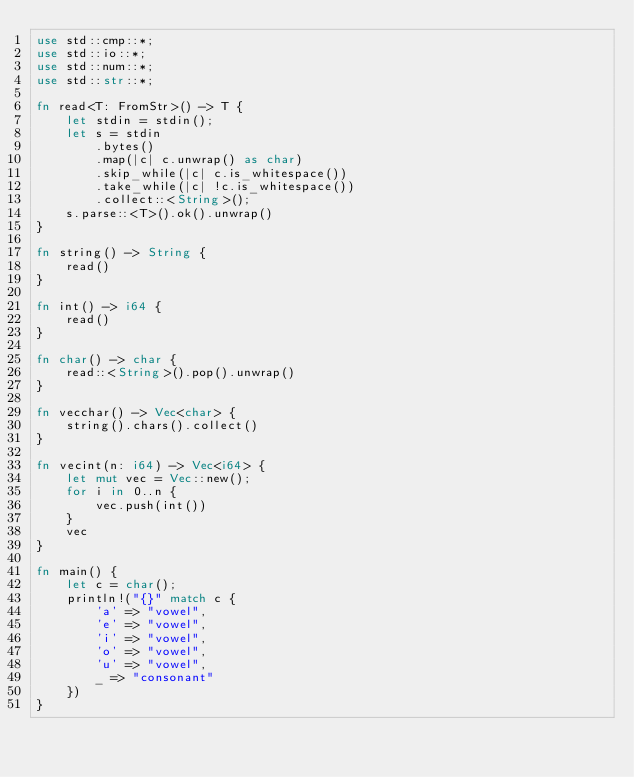Convert code to text. <code><loc_0><loc_0><loc_500><loc_500><_Rust_>use std::cmp::*;
use std::io::*;
use std::num::*;
use std::str::*;

fn read<T: FromStr>() -> T {
    let stdin = stdin();
    let s = stdin
        .bytes()
        .map(|c| c.unwrap() as char)
        .skip_while(|c| c.is_whitespace())
        .take_while(|c| !c.is_whitespace())
        .collect::<String>();
    s.parse::<T>().ok().unwrap()
}

fn string() -> String {
    read()
}

fn int() -> i64 {
    read()
}

fn char() -> char {
    read::<String>().pop().unwrap()
}

fn vecchar() -> Vec<char> {
    string().chars().collect()
}

fn vecint(n: i64) -> Vec<i64> {
    let mut vec = Vec::new();
    for i in 0..n {
        vec.push(int())
    }
    vec
}

fn main() {
    let c = char();
    println!("{}" match c {
        'a' => "vowel",
        'e' => "vowel",
        'i' => "vowel",
        'o' => "vowel",
        'u' => "vowel",
        _ => "consonant"
    })
}
</code> 